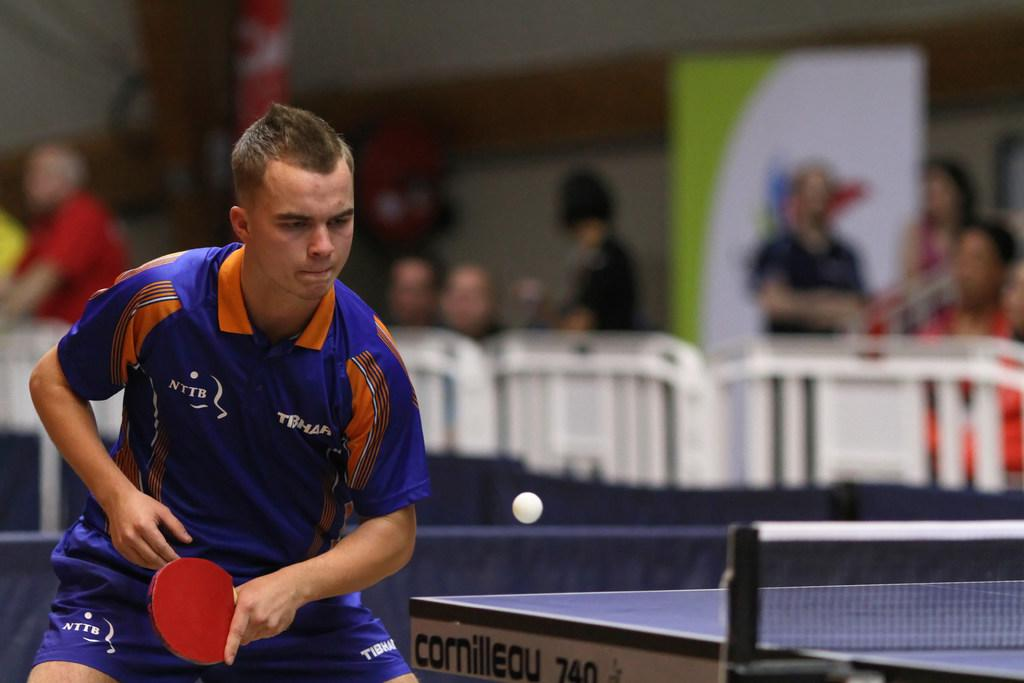What is the person in the image doing? The person is standing and holding a red bat, and they are playing a game. What is the person holding in the image? The person is holding a red bat. What can be seen in the background of the image? There is a group of people and a hoarding in the background of the image. What type of current can be seen flowing through the bat in the image? There is no current flowing through the bat in the image; it is a physical object used for playing a game. 